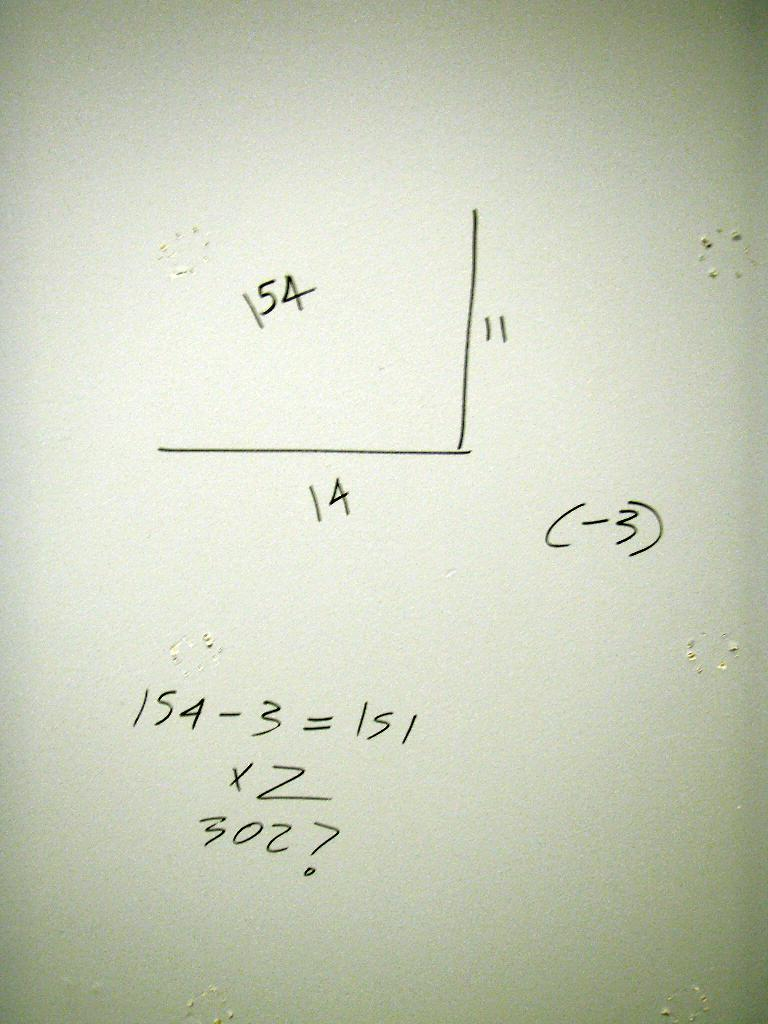<image>
Describe the image concisely. a white board with number 154 in a graph on it 